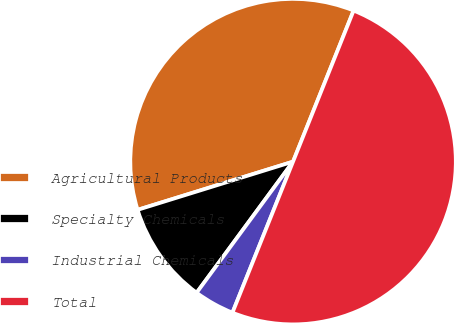<chart> <loc_0><loc_0><loc_500><loc_500><pie_chart><fcel>Agricultural Products<fcel>Specialty Chemicals<fcel>Industrial Chemicals<fcel>Total<nl><fcel>35.85%<fcel>10.12%<fcel>4.02%<fcel>50.0%<nl></chart> 